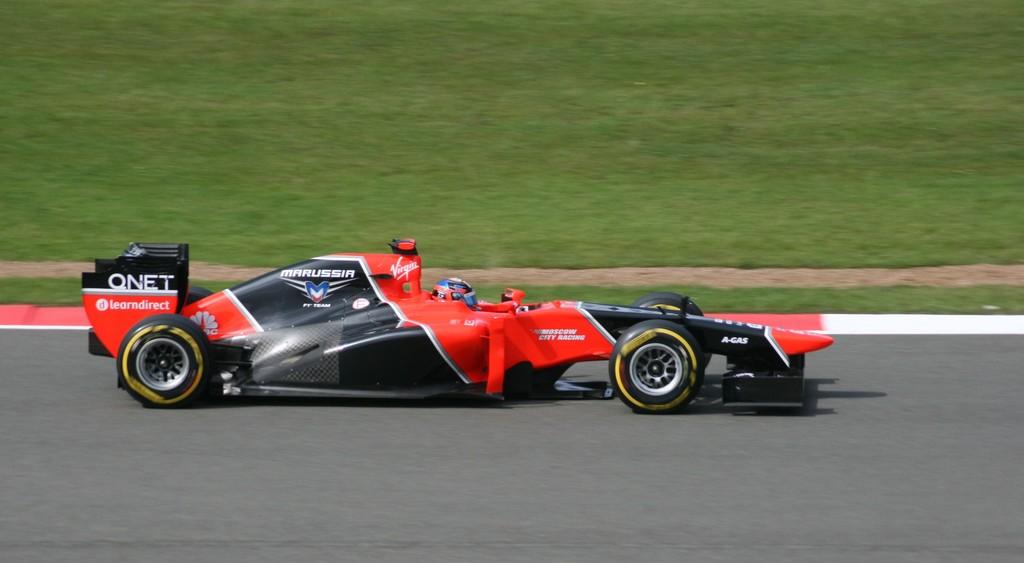What is the person in the image doing? There is a person riding a car in the image. What safety precaution is the person taking while riding the car? The person is wearing a helmet. What type of terrain is visible at the top of the image? Grass is visible at the top of the image. What type of surface is visible at the bottom of the image? There is a road at the bottom of the image. What type of faucet can be seen in the image? There is no faucet present in the image. How many voices can be heard in the image? The image is a still photograph, so no voices can be heard. 